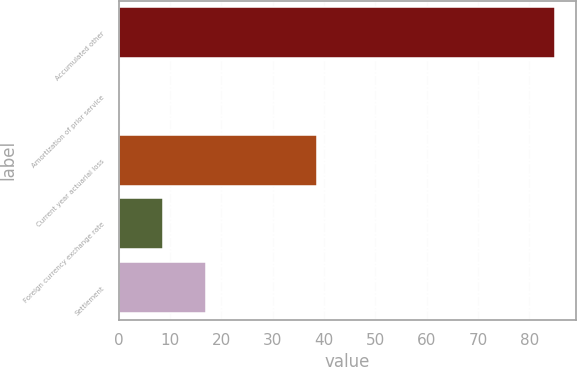<chart> <loc_0><loc_0><loc_500><loc_500><bar_chart><fcel>Accumulated other<fcel>Amortization of prior service<fcel>Current year actuarial loss<fcel>Foreign currency exchange rate<fcel>Settlement<nl><fcel>84.9<fcel>0.1<fcel>38.6<fcel>8.58<fcel>17.06<nl></chart> 